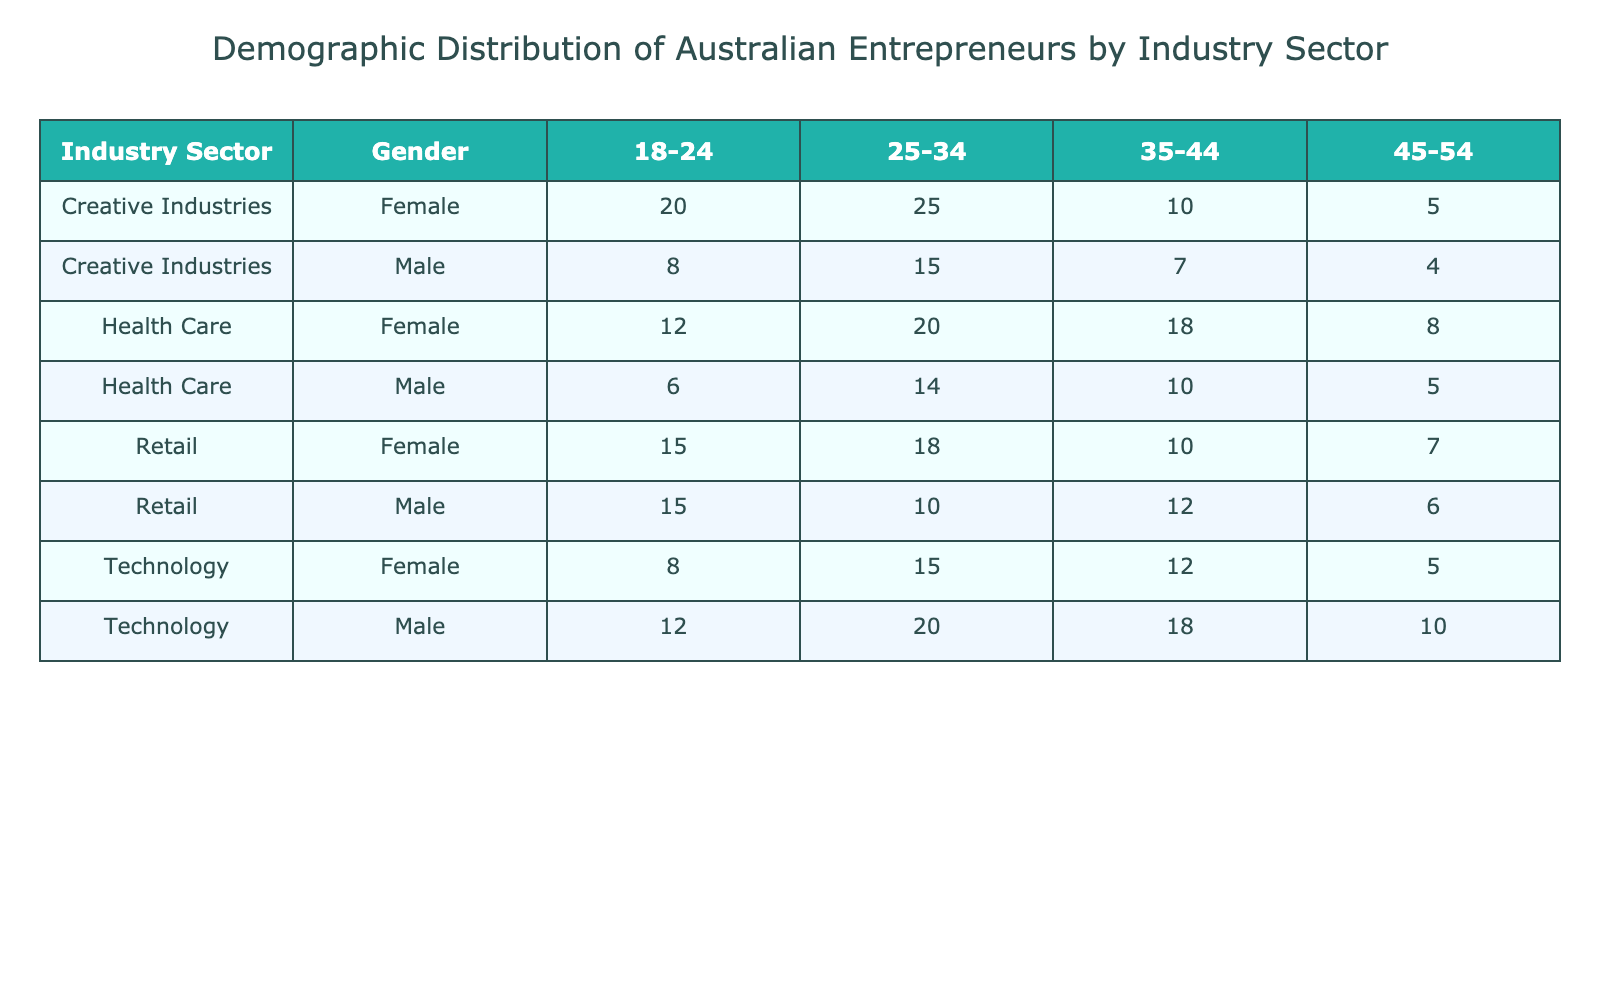What is the percentage of male entrepreneurs aged 35-44 in the technology sector? According to the table, the percentage of male entrepreneurs in the technology sector aged 35-44 is directly listed under that category, which is 18.
Answer: 18 What is the total percentage of female entrepreneurs in the health care sector? To find the total percentage of female entrepreneurs in the health care sector, sum the percentages from the relevant rows: 12 (18-24) + 20 (25-34) + 18 (35-44) + 8 (45-54) = 58.
Answer: 58 Is there a higher percentage of male entrepreneurs in creative industries compared to health care for the age group 25-34? In the creative industries, the percentage of male entrepreneurs aged 25-34 is 15, while in health care it is 14. Since 15 > 14, the statement is true.
Answer: Yes What is the difference in percentage between male and female entrepreneurs aged 18-24 in the retail sector? In the retail sector, the male entrepreneurs aged 18-24 account for 15% and female entrepreneurs account for 15%. The difference is 15 - 15 = 0.
Answer: 0 How does the percentage of female entrepreneurs aged 45-54 in the technology sector compare to the percentage of male entrepreneurs in the same age group? In the technology sector, the percentage of female entrepreneurs aged 45-54 is 5% while the percentage of male entrepreneurs in the same age group is 10%. Since 5% is less than 10%, the female percentage is lower.
Answer: Lower What is the average percentage of female entrepreneurs across all age groups in the retail sector? The percentages of female entrepreneurs in the retail sector are: 15 (18-24) + 18 (25-34) + 10 (35-44) + 7 (45-54). Summing these gives 15 + 18 + 10 + 7 = 50. There are 4 age groups, so the average is 50/4 = 12.5.
Answer: 12.5 Are there more male entrepreneurs aged 25-34 in the creative industries than in the technology sector? The percentage of male entrepreneurs aged 25-34 in creative industries is 15, while in the technology sector it is 20. Since 15 < 20, the statement is false.
Answer: No What is the total percentage of male and female entrepreneurs aged 35-44 in the health care sector? In the health care sector, the percentages of male and female entrepreneurs aged 35-44 are 10 and 18, respectively. By summing these, 10 + 18 = 28, which is the total percentage.
Answer: 28 What is the percentage of entrepreneurs aged 18-24 in the health care sector compared to the technology sector? For the health care sector, it's 6% male and 12% female for the age group 18-24, summing to 6 + 12 = 18%. In the technology sector, it's 12% male and 8% female, summing to 12 + 8 = 20%. Since 18% is less than 20%, the percentage in health care is lower.
Answer: Lower 